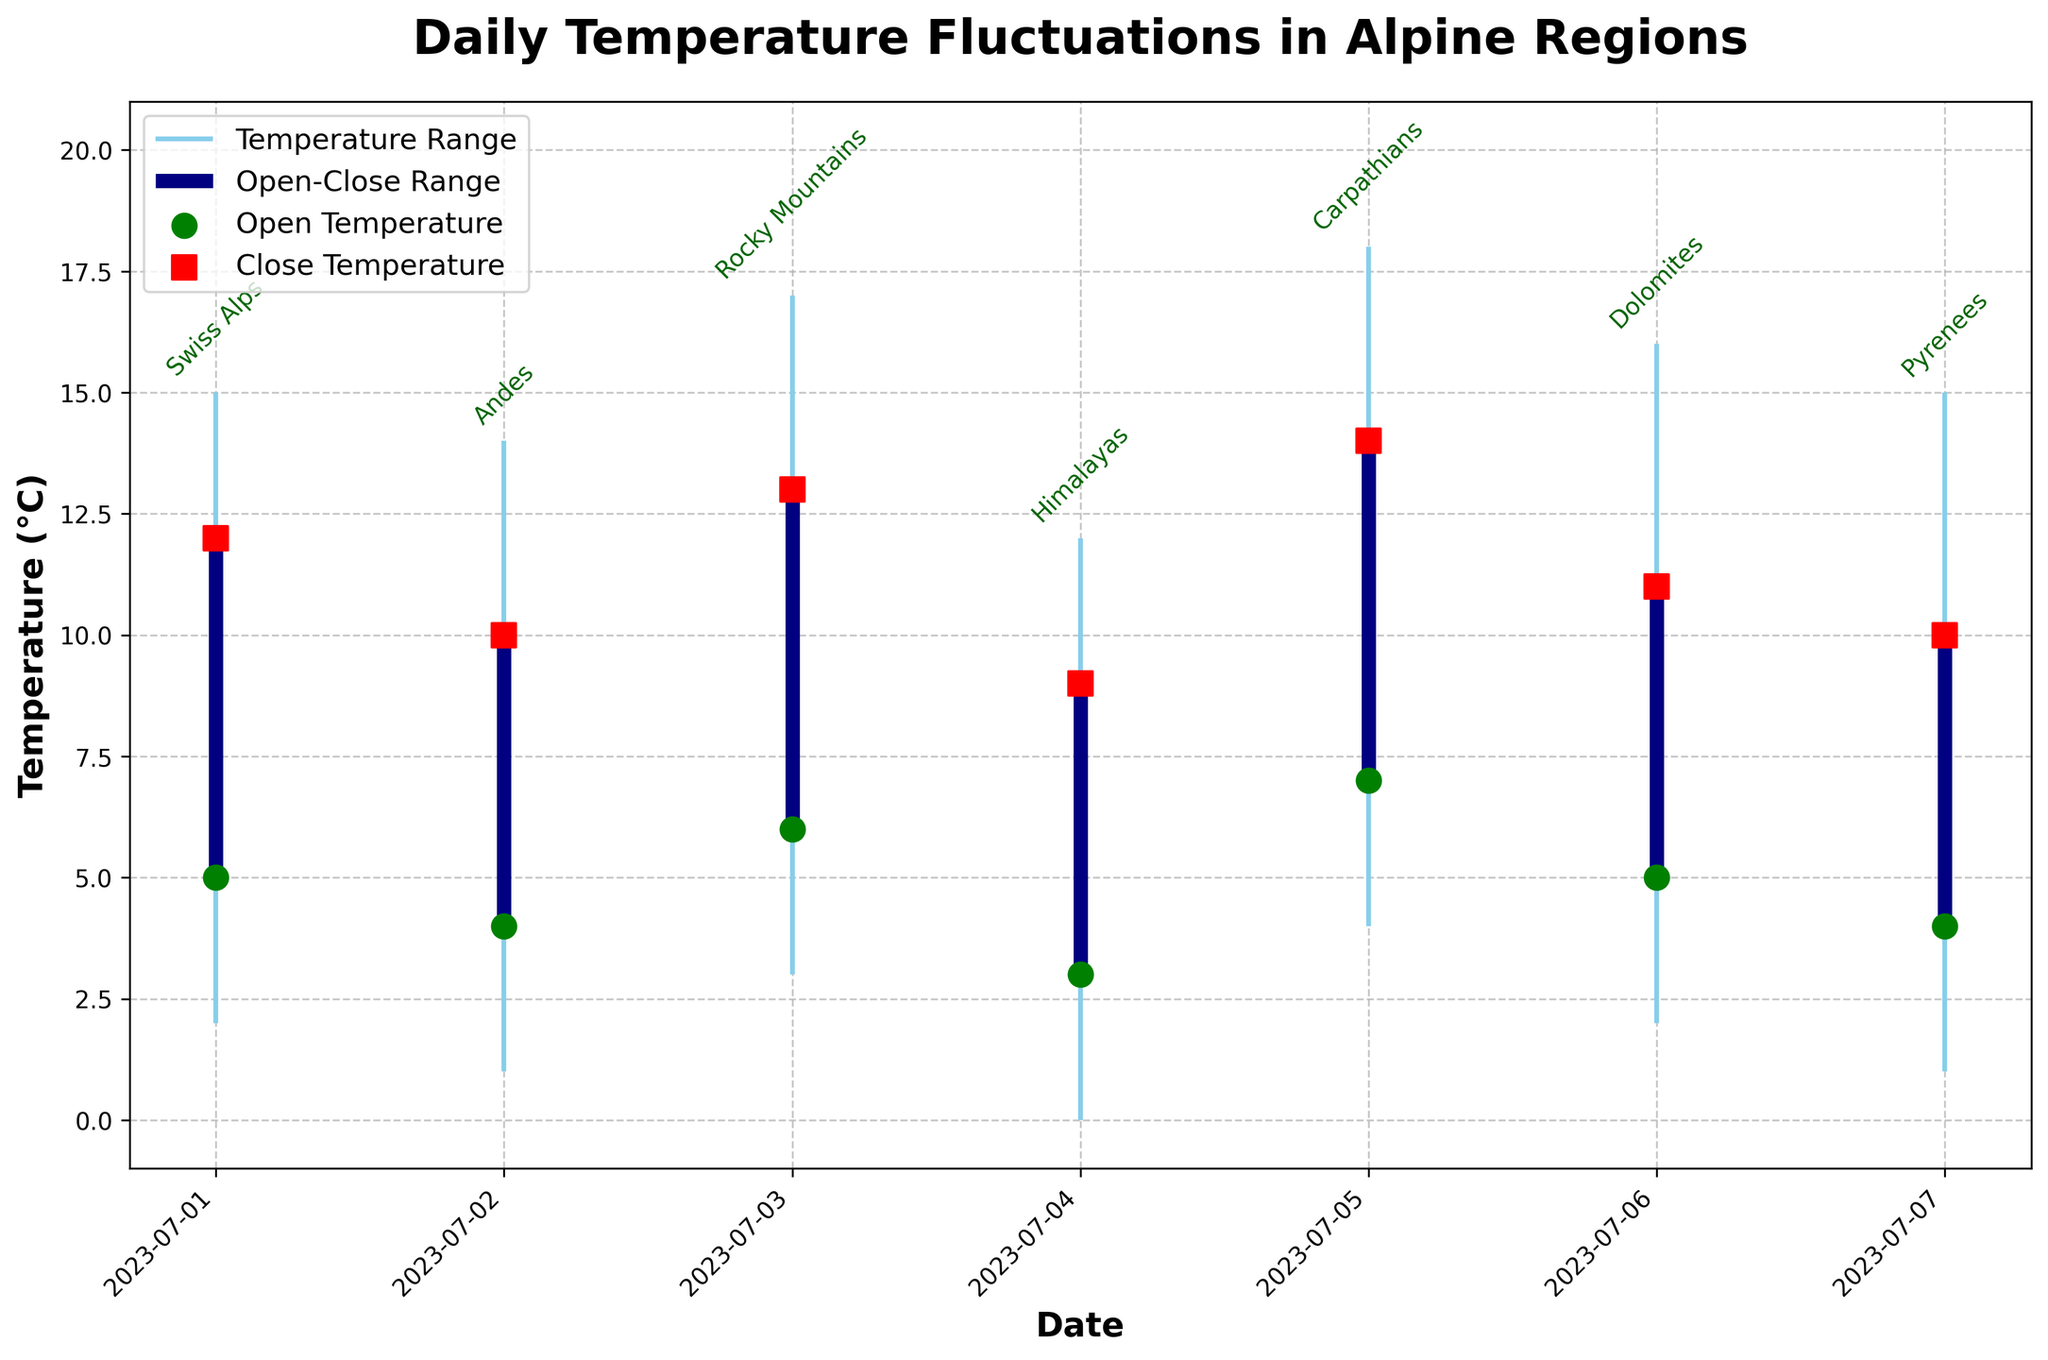What is the title of the chart? The title is typically displayed at the top of the chart. It provides an overview of what the chart represents. Here, it is "Daily Temperature Fluctuations in Alpine Regions"
Answer: Daily Temperature Fluctuations in Alpine Regions Which region shows the highest daily high temperature and what is that temperature? The highest daily high temperature can be identified by observing the tallest vertical line representing the high values. The label next to this line indicates the region. On July 3, the Rocky Mountains reached the highest temperature of 17°C
Answer: Rocky Mountains, 17°C On which date did the region with the lowest daily low temperature experience it, and what was the temperature? Minima are the lowest points of the vertical lines in the chart. The lowest daily low temperature is represented by the shortest vertical line at the bottom. On July 4, the Himalayas experienced the lowest low temperature of 0°C
Answer: July 4, 0°C What is the average opening temperature for the regions over the given dates? To calculate the average open temperature, sum the opening temperatures for all dates (5+4+6+3+7+5+4) and divide by the number of dates (7). The calculation is (5+4+6+3+7+5+4)/7 = 34/7 ≈ 4.86°C
Answer: 4.86°C Which region had the smallest temperature range on its day, and what was the range? The temperature range is found by subtracting the low value from the high value for each day. Compare these values for all regions: Swiss Alps (15-2=13), Andes (14-1=13), Rocky Mountains (17-3=14), Himalayas (12-0=12), Carpathians (18-4=14), Dolomites (16-2=14), Pyrenees (15-1=14). The smallest range is 12°C in the Himalayas on July 4
Answer: Himalayas, 12°C For which date and region did the opening and closing temperatures differ the most, and what was the difference? The difference between opening and closing temperatures can be calculated for each date. Identify the maximum difference: Swiss Alps (12-5=7), Andes (10-4=6), Rocky Mountains (13-6=7), Himalayas (9-3=6), Carpathians (14-7=7), Dolomites (11-5=6), Pyrenees (10-4=6). The maximum difference of 7°C occurs on July 1 (Swiss Alps), July 3 (Rocky Mountains), and July 5 (Carpathians)
Answer: July 1 (Swiss Alps), July 3 (Rocky Mountains), July 5 (Carpathians), 7°C Which day had the largest difference between the highest and lowest temperatures? The difference between the highest and lowest temperature each day can be determined and compared. Swiss Alps (15-2=13), Andes (14-1=13), Rocky Mountains (17-3=14), Himalayas (12-0=12), Carpathians (18-4=14), Dolomites (16-2=14), Pyrenees (15-1=14). The largest difference is 14°C on July 3 (Rocky Mountains), July 5 (Carpathians), and July 6 (Dolomites)
Answer: July 3, July 5, July 6, 14°C What was the closing temperature for the Andes on July 2, and how does it compare to the opening temperature of the following day, July 3, in the Rocky Mountains? The closing temperature for the Andes on July 2 is indicated by the red square on that date, which is 10°C. The opening temperature for the Rocky Mountains on July 3, indicated by the green circle, is 6°C. The difference is 10 - 6 = 4°C, the Andes’ closing temperature is 4°C higher
Answer: Andes (July 2), 10°C; Rocky Mountains (July 3), 6°C; 4°C higher 